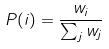Convert formula to latex. <formula><loc_0><loc_0><loc_500><loc_500>P ( i ) = \frac { w _ { i } } { \sum _ { j } w _ { j } }</formula> 